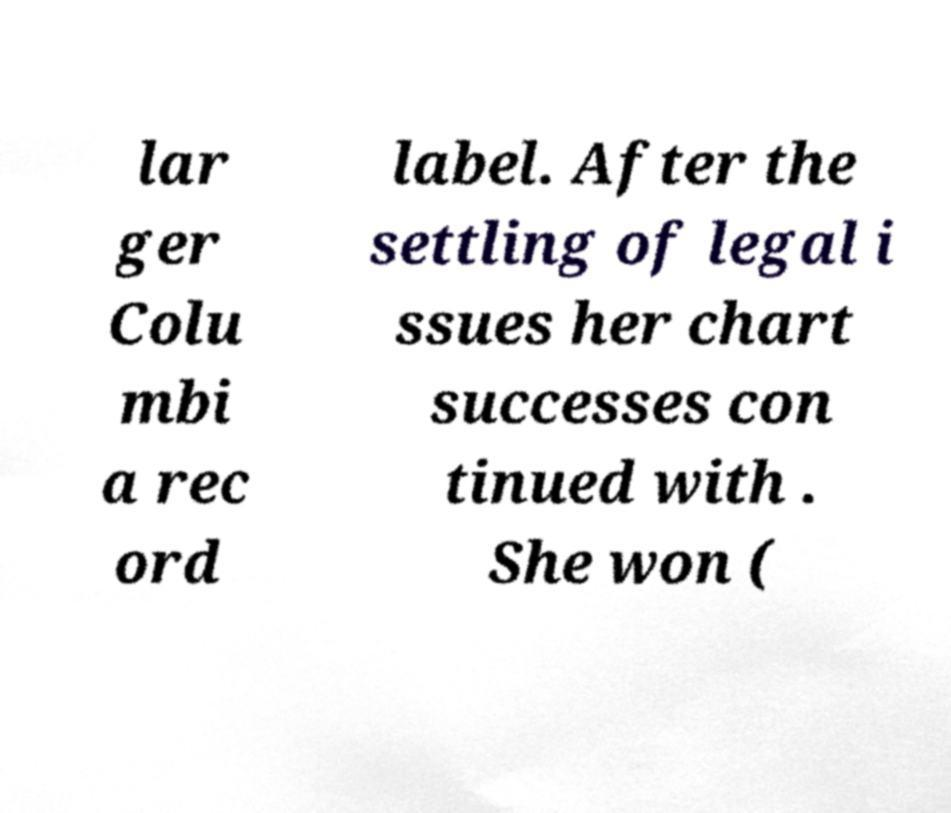Please read and relay the text visible in this image. What does it say? lar ger Colu mbi a rec ord label. After the settling of legal i ssues her chart successes con tinued with . She won ( 